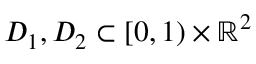<formula> <loc_0><loc_0><loc_500><loc_500>D _ { 1 } , D _ { 2 } \subset [ 0 , 1 ) \times \mathbb { R } ^ { 2 }</formula> 